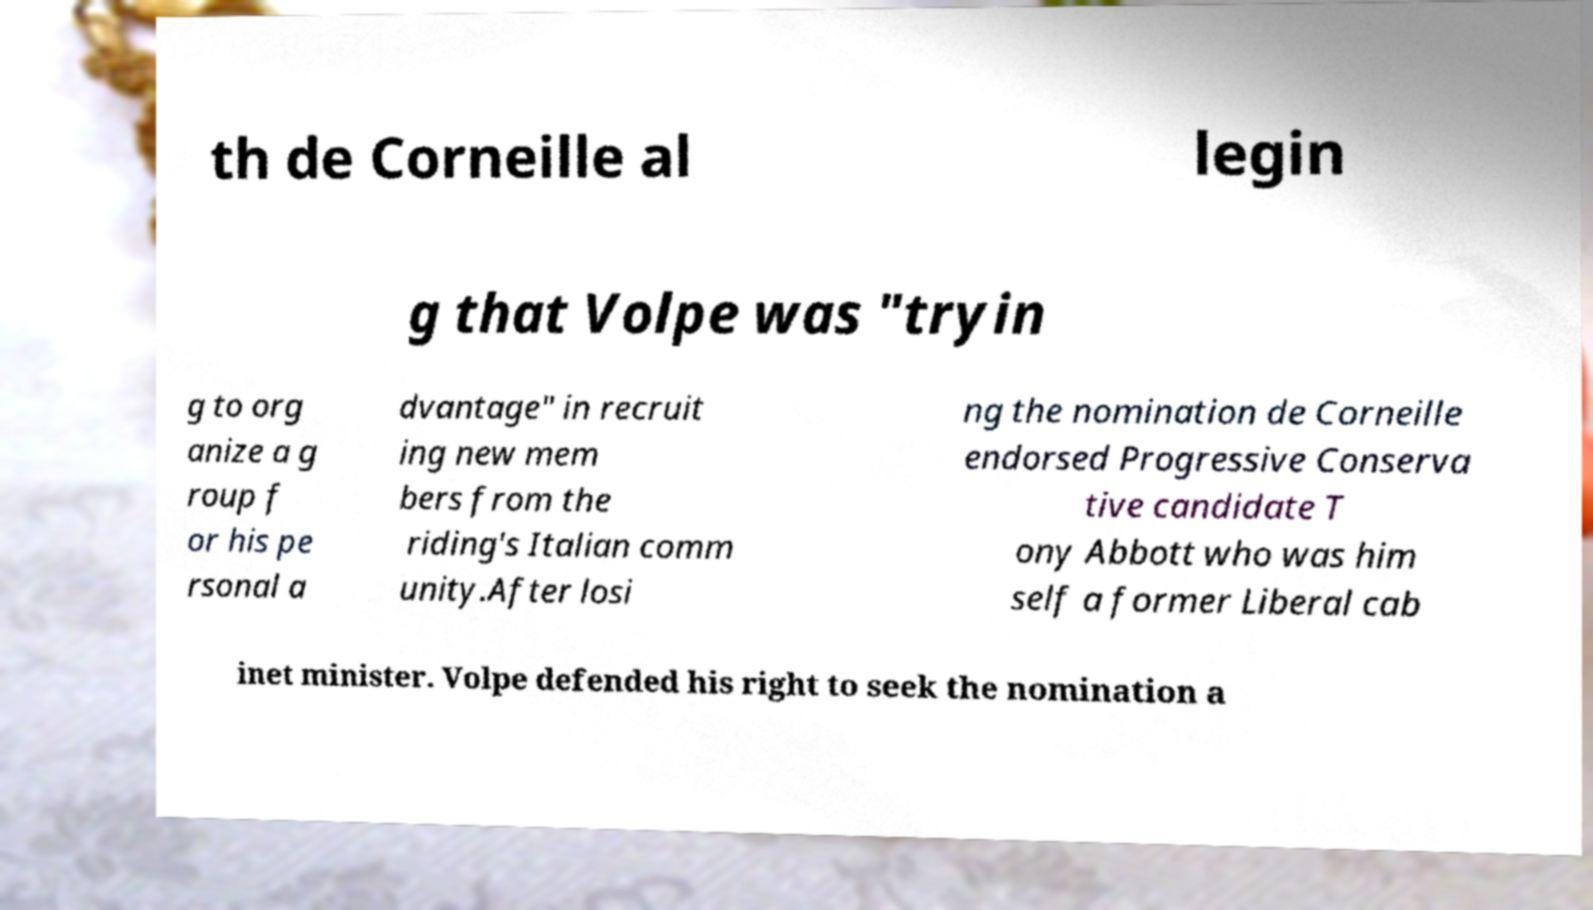For documentation purposes, I need the text within this image transcribed. Could you provide that? th de Corneille al legin g that Volpe was "tryin g to org anize a g roup f or his pe rsonal a dvantage" in recruit ing new mem bers from the riding's Italian comm unity.After losi ng the nomination de Corneille endorsed Progressive Conserva tive candidate T ony Abbott who was him self a former Liberal cab inet minister. Volpe defended his right to seek the nomination a 